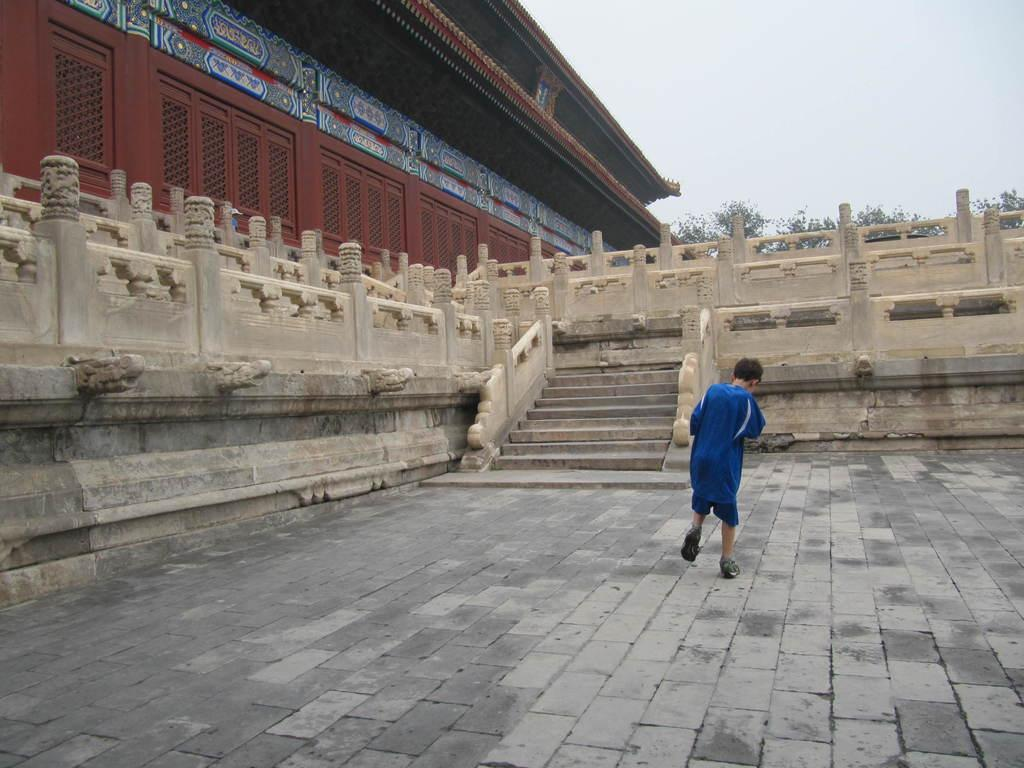What is the person in the image doing? The person is standing on the ground in the image. What type of structure can be seen in the image? There is a building with windows in the image. What are the walls of the building made of? The building has walls, but the material is not specified in the facts. What are the poles in the image used for? The purpose of the poles in the image is not mentioned in the facts. Where is the staircase located in the image? There is a staircase in the image, but its exact location is not specified. What type of vegetation is present in the image? There are trees in the image. What is the weather like in the image? The sky is visible in the image and appears cloudy, suggesting a potentially overcast or partly cloudy day. How many bananas are hanging from the roof in the image? There is no roof or bananas present in the image. What type of road can be seen in the image? There is no road visible in the image. 